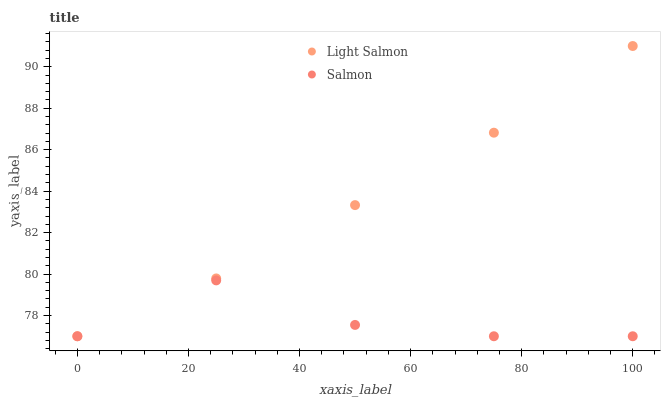Does Salmon have the minimum area under the curve?
Answer yes or no. Yes. Does Light Salmon have the maximum area under the curve?
Answer yes or no. Yes. Does Salmon have the maximum area under the curve?
Answer yes or no. No. Is Light Salmon the smoothest?
Answer yes or no. Yes. Is Salmon the roughest?
Answer yes or no. Yes. Is Salmon the smoothest?
Answer yes or no. No. Does Light Salmon have the lowest value?
Answer yes or no. Yes. Does Light Salmon have the highest value?
Answer yes or no. Yes. Does Salmon have the highest value?
Answer yes or no. No. Does Light Salmon intersect Salmon?
Answer yes or no. Yes. Is Light Salmon less than Salmon?
Answer yes or no. No. Is Light Salmon greater than Salmon?
Answer yes or no. No. 